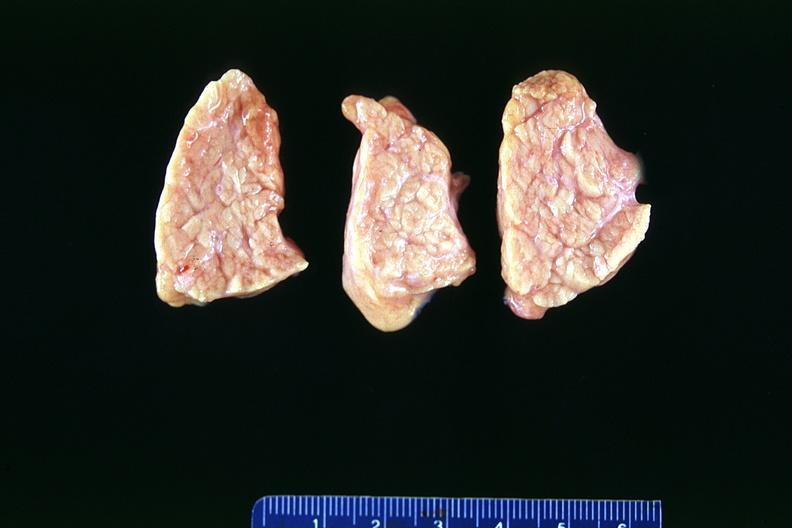what does this image show?
Answer the question using a single word or phrase. Normal pancreas 